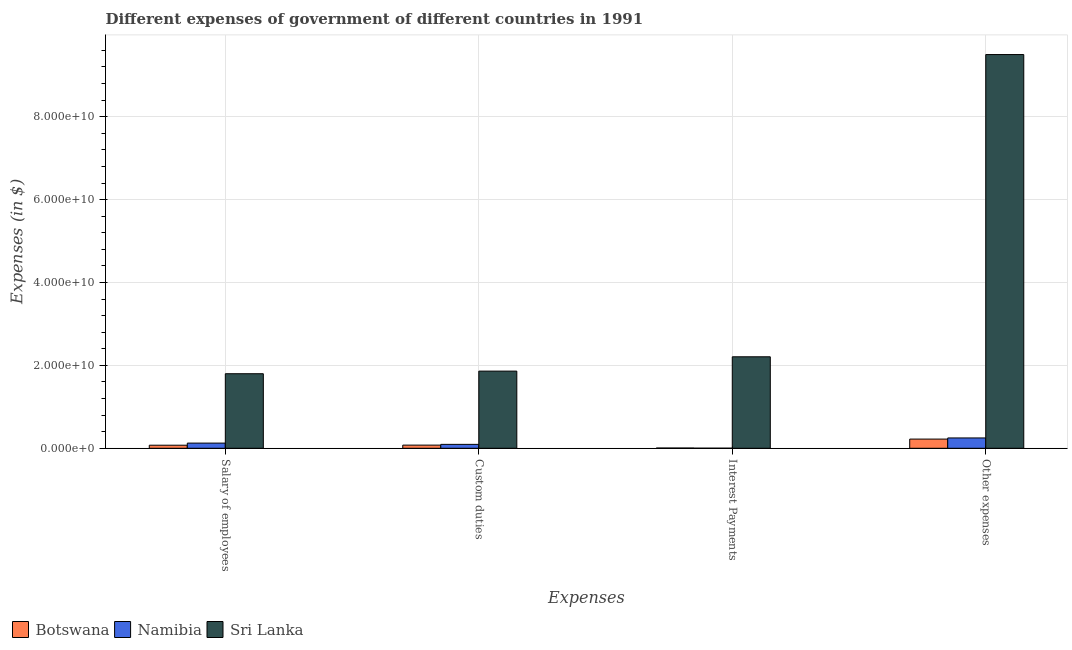Are the number of bars per tick equal to the number of legend labels?
Keep it short and to the point. Yes. How many bars are there on the 3rd tick from the left?
Make the answer very short. 3. What is the label of the 3rd group of bars from the left?
Give a very brief answer. Interest Payments. What is the amount spent on custom duties in Botswana?
Offer a terse response. 7.62e+08. Across all countries, what is the maximum amount spent on other expenses?
Provide a succinct answer. 9.50e+1. Across all countries, what is the minimum amount spent on custom duties?
Your answer should be very brief. 7.62e+08. In which country was the amount spent on other expenses maximum?
Provide a succinct answer. Sri Lanka. In which country was the amount spent on other expenses minimum?
Provide a short and direct response. Botswana. What is the total amount spent on salary of employees in the graph?
Provide a short and direct response. 2.00e+1. What is the difference between the amount spent on interest payments in Botswana and that in Sri Lanka?
Your answer should be very brief. -2.20e+1. What is the difference between the amount spent on other expenses in Namibia and the amount spent on custom duties in Botswana?
Your answer should be compact. 1.73e+09. What is the average amount spent on custom duties per country?
Keep it short and to the point. 6.77e+09. What is the difference between the amount spent on interest payments and amount spent on salary of employees in Botswana?
Make the answer very short. -6.78e+08. In how many countries, is the amount spent on interest payments greater than 52000000000 $?
Offer a very short reply. 0. What is the ratio of the amount spent on interest payments in Botswana to that in Namibia?
Offer a very short reply. 2.9. Is the difference between the amount spent on custom duties in Sri Lanka and Botswana greater than the difference between the amount spent on other expenses in Sri Lanka and Botswana?
Your answer should be compact. No. What is the difference between the highest and the second highest amount spent on salary of employees?
Your answer should be compact. 1.67e+1. What is the difference between the highest and the lowest amount spent on interest payments?
Offer a terse response. 2.21e+1. In how many countries, is the amount spent on other expenses greater than the average amount spent on other expenses taken over all countries?
Provide a succinct answer. 1. Is the sum of the amount spent on salary of employees in Sri Lanka and Namibia greater than the maximum amount spent on interest payments across all countries?
Give a very brief answer. No. Is it the case that in every country, the sum of the amount spent on salary of employees and amount spent on interest payments is greater than the sum of amount spent on custom duties and amount spent on other expenses?
Your answer should be compact. No. What does the 3rd bar from the left in Custom duties represents?
Your answer should be compact. Sri Lanka. What does the 2nd bar from the right in Interest Payments represents?
Your answer should be very brief. Namibia. How many bars are there?
Your answer should be very brief. 12. Where does the legend appear in the graph?
Give a very brief answer. Bottom left. How many legend labels are there?
Provide a succinct answer. 3. What is the title of the graph?
Make the answer very short. Different expenses of government of different countries in 1991. Does "Philippines" appear as one of the legend labels in the graph?
Your response must be concise. No. What is the label or title of the X-axis?
Your response must be concise. Expenses. What is the label or title of the Y-axis?
Offer a very short reply. Expenses (in $). What is the Expenses (in $) in Botswana in Salary of employees?
Your answer should be very brief. 7.39e+08. What is the Expenses (in $) of Namibia in Salary of employees?
Keep it short and to the point. 1.25e+09. What is the Expenses (in $) in Sri Lanka in Salary of employees?
Offer a very short reply. 1.80e+1. What is the Expenses (in $) of Botswana in Custom duties?
Make the answer very short. 7.62e+08. What is the Expenses (in $) of Namibia in Custom duties?
Your response must be concise. 9.46e+08. What is the Expenses (in $) in Sri Lanka in Custom duties?
Your response must be concise. 1.86e+1. What is the Expenses (in $) of Botswana in Interest Payments?
Make the answer very short. 6.07e+07. What is the Expenses (in $) in Namibia in Interest Payments?
Offer a very short reply. 2.09e+07. What is the Expenses (in $) in Sri Lanka in Interest Payments?
Give a very brief answer. 2.21e+1. What is the Expenses (in $) of Botswana in Other expenses?
Offer a very short reply. 2.22e+09. What is the Expenses (in $) of Namibia in Other expenses?
Offer a terse response. 2.49e+09. What is the Expenses (in $) of Sri Lanka in Other expenses?
Make the answer very short. 9.50e+1. Across all Expenses, what is the maximum Expenses (in $) in Botswana?
Offer a terse response. 2.22e+09. Across all Expenses, what is the maximum Expenses (in $) of Namibia?
Offer a very short reply. 2.49e+09. Across all Expenses, what is the maximum Expenses (in $) in Sri Lanka?
Give a very brief answer. 9.50e+1. Across all Expenses, what is the minimum Expenses (in $) in Botswana?
Your answer should be compact. 6.07e+07. Across all Expenses, what is the minimum Expenses (in $) in Namibia?
Offer a very short reply. 2.09e+07. Across all Expenses, what is the minimum Expenses (in $) in Sri Lanka?
Your answer should be compact. 1.80e+1. What is the total Expenses (in $) of Botswana in the graph?
Your response must be concise. 3.78e+09. What is the total Expenses (in $) in Namibia in the graph?
Provide a short and direct response. 4.71e+09. What is the total Expenses (in $) of Sri Lanka in the graph?
Keep it short and to the point. 1.54e+11. What is the difference between the Expenses (in $) in Botswana in Salary of employees and that in Custom duties?
Give a very brief answer. -2.27e+07. What is the difference between the Expenses (in $) of Namibia in Salary of employees and that in Custom duties?
Your response must be concise. 3.04e+08. What is the difference between the Expenses (in $) in Sri Lanka in Salary of employees and that in Custom duties?
Make the answer very short. -6.32e+08. What is the difference between the Expenses (in $) in Botswana in Salary of employees and that in Interest Payments?
Provide a short and direct response. 6.78e+08. What is the difference between the Expenses (in $) in Namibia in Salary of employees and that in Interest Payments?
Provide a succinct answer. 1.23e+09. What is the difference between the Expenses (in $) in Sri Lanka in Salary of employees and that in Interest Payments?
Ensure brevity in your answer.  -4.09e+09. What is the difference between the Expenses (in $) of Botswana in Salary of employees and that in Other expenses?
Give a very brief answer. -1.48e+09. What is the difference between the Expenses (in $) in Namibia in Salary of employees and that in Other expenses?
Make the answer very short. -1.24e+09. What is the difference between the Expenses (in $) of Sri Lanka in Salary of employees and that in Other expenses?
Offer a terse response. -7.70e+1. What is the difference between the Expenses (in $) in Botswana in Custom duties and that in Interest Payments?
Your answer should be very brief. 7.01e+08. What is the difference between the Expenses (in $) of Namibia in Custom duties and that in Interest Payments?
Your response must be concise. 9.25e+08. What is the difference between the Expenses (in $) in Sri Lanka in Custom duties and that in Interest Payments?
Offer a terse response. -3.46e+09. What is the difference between the Expenses (in $) of Botswana in Custom duties and that in Other expenses?
Give a very brief answer. -1.46e+09. What is the difference between the Expenses (in $) in Namibia in Custom duties and that in Other expenses?
Offer a very short reply. -1.55e+09. What is the difference between the Expenses (in $) in Sri Lanka in Custom duties and that in Other expenses?
Your answer should be very brief. -7.64e+1. What is the difference between the Expenses (in $) in Botswana in Interest Payments and that in Other expenses?
Give a very brief answer. -2.16e+09. What is the difference between the Expenses (in $) in Namibia in Interest Payments and that in Other expenses?
Keep it short and to the point. -2.47e+09. What is the difference between the Expenses (in $) in Sri Lanka in Interest Payments and that in Other expenses?
Keep it short and to the point. -7.29e+1. What is the difference between the Expenses (in $) in Botswana in Salary of employees and the Expenses (in $) in Namibia in Custom duties?
Your answer should be compact. -2.07e+08. What is the difference between the Expenses (in $) in Botswana in Salary of employees and the Expenses (in $) in Sri Lanka in Custom duties?
Give a very brief answer. -1.79e+1. What is the difference between the Expenses (in $) in Namibia in Salary of employees and the Expenses (in $) in Sri Lanka in Custom duties?
Make the answer very short. -1.74e+1. What is the difference between the Expenses (in $) of Botswana in Salary of employees and the Expenses (in $) of Namibia in Interest Payments?
Provide a succinct answer. 7.18e+08. What is the difference between the Expenses (in $) in Botswana in Salary of employees and the Expenses (in $) in Sri Lanka in Interest Payments?
Your answer should be very brief. -2.13e+1. What is the difference between the Expenses (in $) of Namibia in Salary of employees and the Expenses (in $) of Sri Lanka in Interest Payments?
Your response must be concise. -2.08e+1. What is the difference between the Expenses (in $) in Botswana in Salary of employees and the Expenses (in $) in Namibia in Other expenses?
Your answer should be compact. -1.75e+09. What is the difference between the Expenses (in $) of Botswana in Salary of employees and the Expenses (in $) of Sri Lanka in Other expenses?
Keep it short and to the point. -9.42e+1. What is the difference between the Expenses (in $) of Namibia in Salary of employees and the Expenses (in $) of Sri Lanka in Other expenses?
Your answer should be compact. -9.37e+1. What is the difference between the Expenses (in $) in Botswana in Custom duties and the Expenses (in $) in Namibia in Interest Payments?
Your response must be concise. 7.41e+08. What is the difference between the Expenses (in $) of Botswana in Custom duties and the Expenses (in $) of Sri Lanka in Interest Payments?
Provide a short and direct response. -2.13e+1. What is the difference between the Expenses (in $) of Namibia in Custom duties and the Expenses (in $) of Sri Lanka in Interest Payments?
Your response must be concise. -2.11e+1. What is the difference between the Expenses (in $) of Botswana in Custom duties and the Expenses (in $) of Namibia in Other expenses?
Give a very brief answer. -1.73e+09. What is the difference between the Expenses (in $) of Botswana in Custom duties and the Expenses (in $) of Sri Lanka in Other expenses?
Ensure brevity in your answer.  -9.42e+1. What is the difference between the Expenses (in $) of Namibia in Custom duties and the Expenses (in $) of Sri Lanka in Other expenses?
Provide a short and direct response. -9.40e+1. What is the difference between the Expenses (in $) of Botswana in Interest Payments and the Expenses (in $) of Namibia in Other expenses?
Provide a succinct answer. -2.43e+09. What is the difference between the Expenses (in $) of Botswana in Interest Payments and the Expenses (in $) of Sri Lanka in Other expenses?
Keep it short and to the point. -9.49e+1. What is the difference between the Expenses (in $) of Namibia in Interest Payments and the Expenses (in $) of Sri Lanka in Other expenses?
Offer a terse response. -9.50e+1. What is the average Expenses (in $) of Botswana per Expenses?
Provide a short and direct response. 9.45e+08. What is the average Expenses (in $) of Namibia per Expenses?
Offer a very short reply. 1.18e+09. What is the average Expenses (in $) in Sri Lanka per Expenses?
Your answer should be compact. 3.84e+1. What is the difference between the Expenses (in $) of Botswana and Expenses (in $) of Namibia in Salary of employees?
Offer a very short reply. -5.11e+08. What is the difference between the Expenses (in $) of Botswana and Expenses (in $) of Sri Lanka in Salary of employees?
Offer a very short reply. -1.72e+1. What is the difference between the Expenses (in $) of Namibia and Expenses (in $) of Sri Lanka in Salary of employees?
Provide a succinct answer. -1.67e+1. What is the difference between the Expenses (in $) of Botswana and Expenses (in $) of Namibia in Custom duties?
Keep it short and to the point. -1.84e+08. What is the difference between the Expenses (in $) of Botswana and Expenses (in $) of Sri Lanka in Custom duties?
Make the answer very short. -1.79e+1. What is the difference between the Expenses (in $) in Namibia and Expenses (in $) in Sri Lanka in Custom duties?
Offer a terse response. -1.77e+1. What is the difference between the Expenses (in $) in Botswana and Expenses (in $) in Namibia in Interest Payments?
Keep it short and to the point. 3.98e+07. What is the difference between the Expenses (in $) of Botswana and Expenses (in $) of Sri Lanka in Interest Payments?
Your response must be concise. -2.20e+1. What is the difference between the Expenses (in $) in Namibia and Expenses (in $) in Sri Lanka in Interest Payments?
Keep it short and to the point. -2.21e+1. What is the difference between the Expenses (in $) in Botswana and Expenses (in $) in Namibia in Other expenses?
Provide a succinct answer. -2.74e+08. What is the difference between the Expenses (in $) in Botswana and Expenses (in $) in Sri Lanka in Other expenses?
Provide a short and direct response. -9.28e+1. What is the difference between the Expenses (in $) in Namibia and Expenses (in $) in Sri Lanka in Other expenses?
Make the answer very short. -9.25e+1. What is the ratio of the Expenses (in $) of Botswana in Salary of employees to that in Custom duties?
Provide a short and direct response. 0.97. What is the ratio of the Expenses (in $) in Namibia in Salary of employees to that in Custom duties?
Make the answer very short. 1.32. What is the ratio of the Expenses (in $) in Sri Lanka in Salary of employees to that in Custom duties?
Your answer should be very brief. 0.97. What is the ratio of the Expenses (in $) of Botswana in Salary of employees to that in Interest Payments?
Give a very brief answer. 12.17. What is the ratio of the Expenses (in $) of Namibia in Salary of employees to that in Interest Payments?
Offer a very short reply. 59.78. What is the ratio of the Expenses (in $) of Sri Lanka in Salary of employees to that in Interest Payments?
Your answer should be compact. 0.81. What is the ratio of the Expenses (in $) in Botswana in Salary of employees to that in Other expenses?
Ensure brevity in your answer.  0.33. What is the ratio of the Expenses (in $) in Namibia in Salary of employees to that in Other expenses?
Make the answer very short. 0.5. What is the ratio of the Expenses (in $) in Sri Lanka in Salary of employees to that in Other expenses?
Make the answer very short. 0.19. What is the ratio of the Expenses (in $) in Botswana in Custom duties to that in Interest Payments?
Provide a short and direct response. 12.55. What is the ratio of the Expenses (in $) of Namibia in Custom duties to that in Interest Payments?
Make the answer very short. 45.25. What is the ratio of the Expenses (in $) in Sri Lanka in Custom duties to that in Interest Payments?
Offer a very short reply. 0.84. What is the ratio of the Expenses (in $) in Botswana in Custom duties to that in Other expenses?
Offer a very short reply. 0.34. What is the ratio of the Expenses (in $) in Namibia in Custom duties to that in Other expenses?
Ensure brevity in your answer.  0.38. What is the ratio of the Expenses (in $) of Sri Lanka in Custom duties to that in Other expenses?
Your answer should be very brief. 0.2. What is the ratio of the Expenses (in $) of Botswana in Interest Payments to that in Other expenses?
Your answer should be compact. 0.03. What is the ratio of the Expenses (in $) of Namibia in Interest Payments to that in Other expenses?
Provide a short and direct response. 0.01. What is the ratio of the Expenses (in $) in Sri Lanka in Interest Payments to that in Other expenses?
Your answer should be compact. 0.23. What is the difference between the highest and the second highest Expenses (in $) of Botswana?
Offer a terse response. 1.46e+09. What is the difference between the highest and the second highest Expenses (in $) of Namibia?
Provide a short and direct response. 1.24e+09. What is the difference between the highest and the second highest Expenses (in $) in Sri Lanka?
Your response must be concise. 7.29e+1. What is the difference between the highest and the lowest Expenses (in $) in Botswana?
Offer a very short reply. 2.16e+09. What is the difference between the highest and the lowest Expenses (in $) of Namibia?
Provide a succinct answer. 2.47e+09. What is the difference between the highest and the lowest Expenses (in $) in Sri Lanka?
Ensure brevity in your answer.  7.70e+1. 